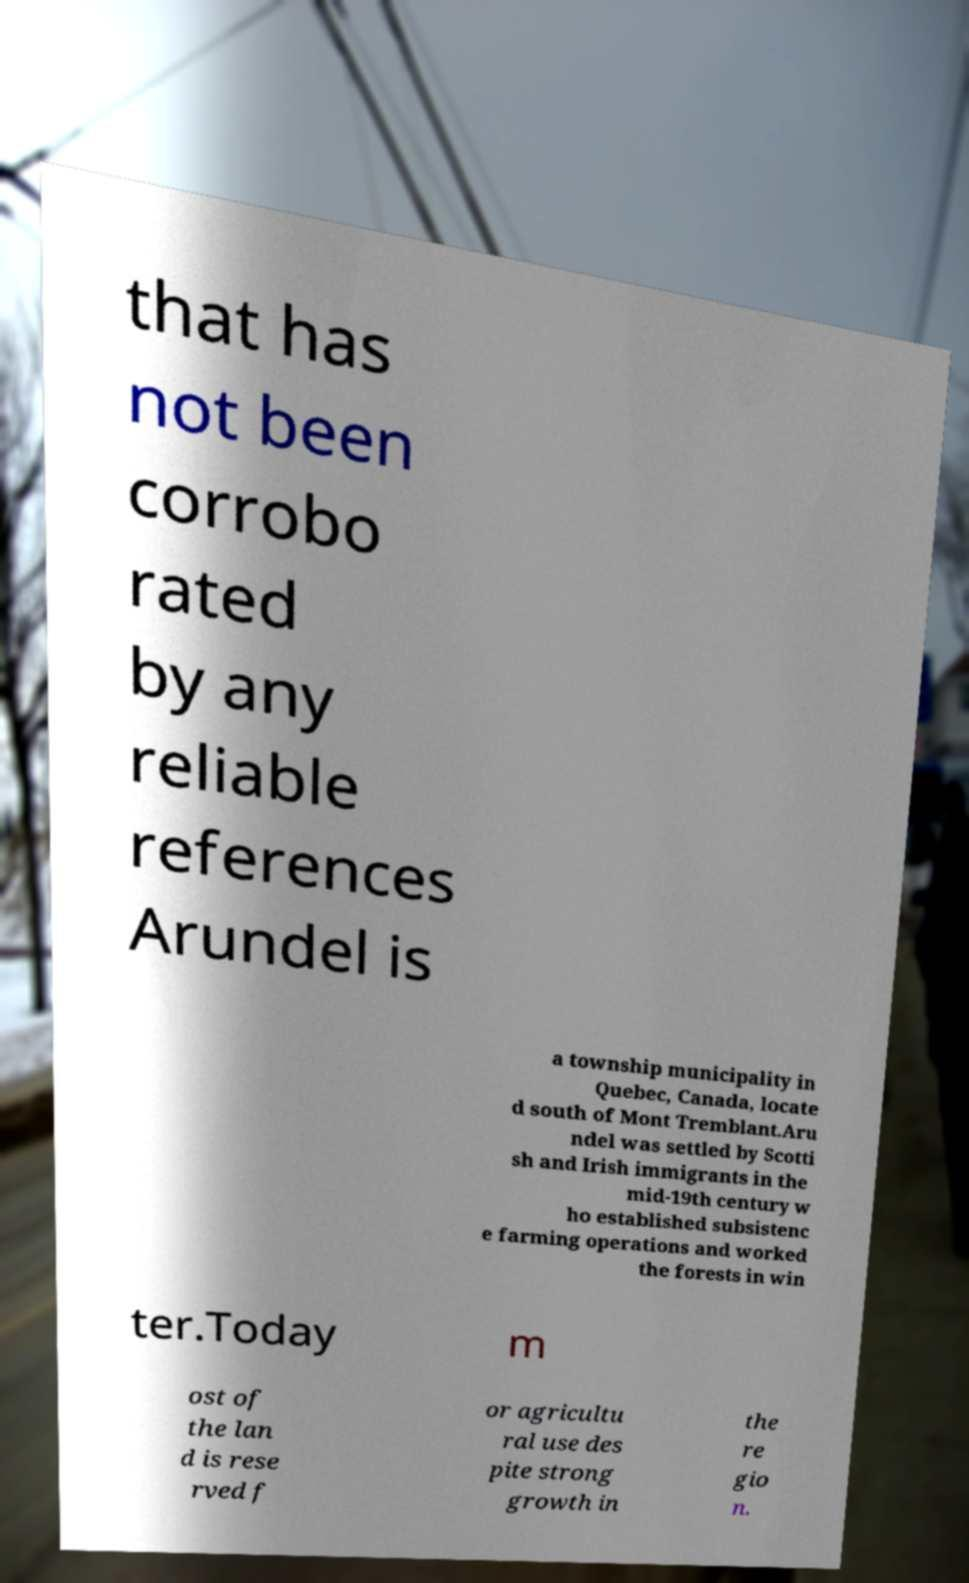There's text embedded in this image that I need extracted. Can you transcribe it verbatim? that has not been corrobo rated by any reliable references Arundel is a township municipality in Quebec, Canada, locate d south of Mont Tremblant.Aru ndel was settled by Scotti sh and Irish immigrants in the mid-19th century w ho established subsistenc e farming operations and worked the forests in win ter.Today m ost of the lan d is rese rved f or agricultu ral use des pite strong growth in the re gio n. 